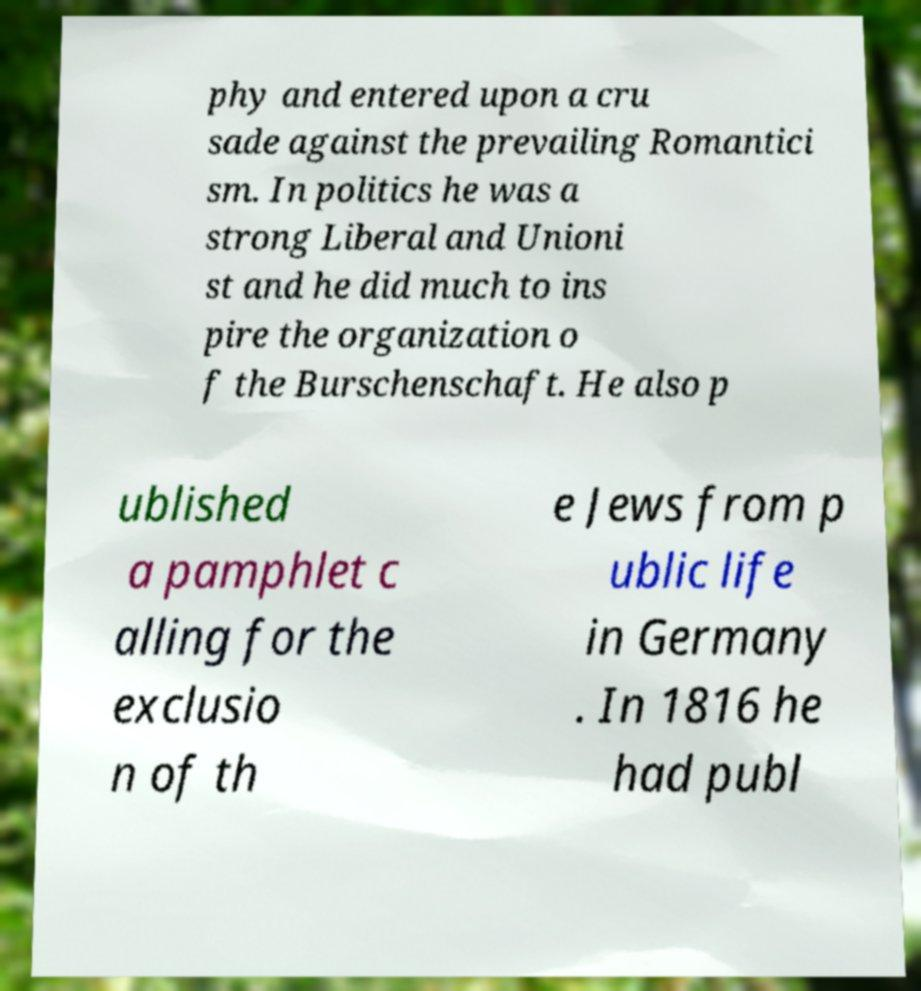There's text embedded in this image that I need extracted. Can you transcribe it verbatim? phy and entered upon a cru sade against the prevailing Romantici sm. In politics he was a strong Liberal and Unioni st and he did much to ins pire the organization o f the Burschenschaft. He also p ublished a pamphlet c alling for the exclusio n of th e Jews from p ublic life in Germany . In 1816 he had publ 